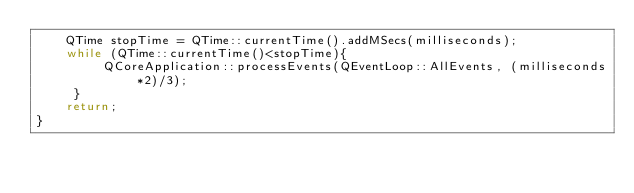<code> <loc_0><loc_0><loc_500><loc_500><_C++_>    QTime stopTime = QTime::currentTime().addMSecs(milliseconds);
    while (QTime::currentTime()<stopTime){
         QCoreApplication::processEvents(QEventLoop::AllEvents, (milliseconds*2)/3);
     }
    return;
}
</code> 